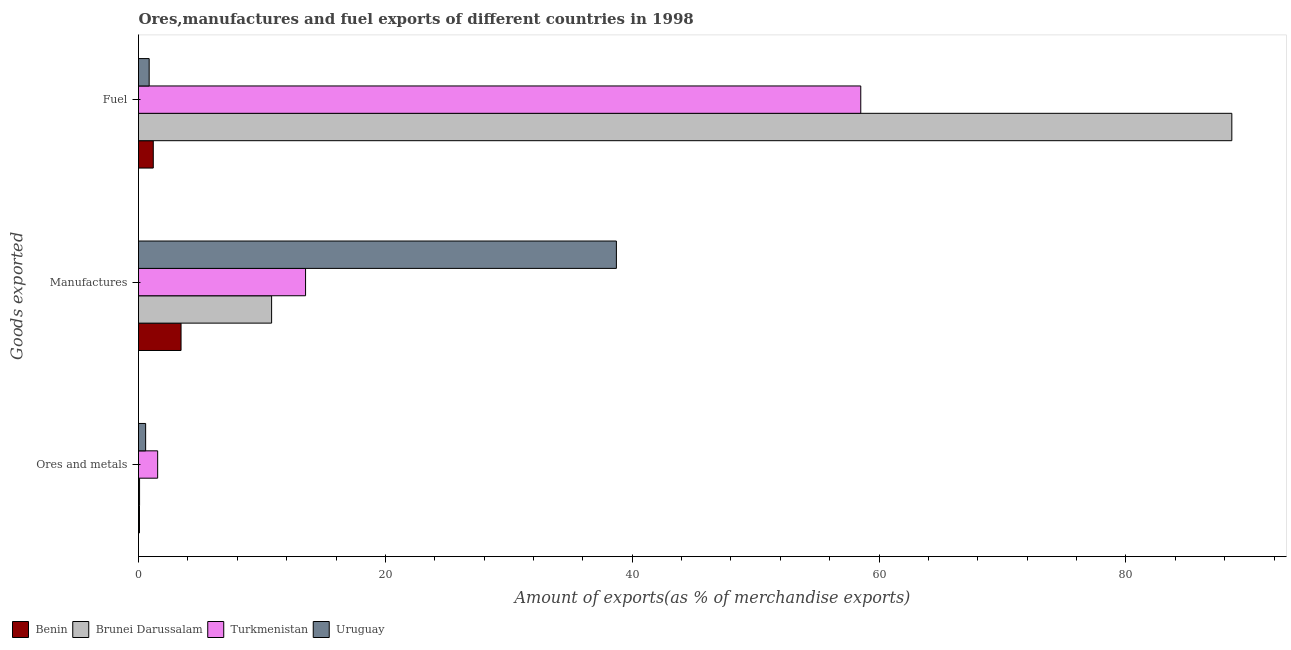How many different coloured bars are there?
Give a very brief answer. 4. How many groups of bars are there?
Your answer should be very brief. 3. Are the number of bars per tick equal to the number of legend labels?
Your answer should be compact. Yes. How many bars are there on the 3rd tick from the top?
Your response must be concise. 4. What is the label of the 3rd group of bars from the top?
Make the answer very short. Ores and metals. What is the percentage of fuel exports in Brunei Darussalam?
Provide a short and direct response. 88.58. Across all countries, what is the maximum percentage of fuel exports?
Offer a very short reply. 88.58. Across all countries, what is the minimum percentage of manufactures exports?
Offer a very short reply. 3.45. In which country was the percentage of manufactures exports maximum?
Offer a terse response. Uruguay. In which country was the percentage of fuel exports minimum?
Make the answer very short. Uruguay. What is the total percentage of fuel exports in the graph?
Provide a short and direct response. 149.15. What is the difference between the percentage of fuel exports in Turkmenistan and that in Brunei Darussalam?
Provide a succinct answer. -30.06. What is the difference between the percentage of manufactures exports in Turkmenistan and the percentage of fuel exports in Uruguay?
Ensure brevity in your answer.  12.67. What is the average percentage of ores and metals exports per country?
Keep it short and to the point. 0.57. What is the difference between the percentage of ores and metals exports and percentage of fuel exports in Brunei Darussalam?
Offer a very short reply. -88.49. In how many countries, is the percentage of fuel exports greater than 44 %?
Ensure brevity in your answer.  2. What is the ratio of the percentage of fuel exports in Brunei Darussalam to that in Uruguay?
Give a very brief answer. 102.54. Is the percentage of manufactures exports in Brunei Darussalam less than that in Uruguay?
Keep it short and to the point. Yes. Is the difference between the percentage of manufactures exports in Turkmenistan and Benin greater than the difference between the percentage of fuel exports in Turkmenistan and Benin?
Give a very brief answer. No. What is the difference between the highest and the second highest percentage of manufactures exports?
Keep it short and to the point. 25.18. What is the difference between the highest and the lowest percentage of ores and metals exports?
Give a very brief answer. 1.47. In how many countries, is the percentage of ores and metals exports greater than the average percentage of ores and metals exports taken over all countries?
Give a very brief answer. 2. What does the 2nd bar from the top in Ores and metals represents?
Your answer should be very brief. Turkmenistan. What does the 4th bar from the bottom in Manufactures represents?
Provide a succinct answer. Uruguay. Is it the case that in every country, the sum of the percentage of ores and metals exports and percentage of manufactures exports is greater than the percentage of fuel exports?
Provide a succinct answer. No. Are the values on the major ticks of X-axis written in scientific E-notation?
Your answer should be compact. No. How many legend labels are there?
Keep it short and to the point. 4. What is the title of the graph?
Ensure brevity in your answer.  Ores,manufactures and fuel exports of different countries in 1998. Does "Angola" appear as one of the legend labels in the graph?
Ensure brevity in your answer.  No. What is the label or title of the X-axis?
Ensure brevity in your answer.  Amount of exports(as % of merchandise exports). What is the label or title of the Y-axis?
Keep it short and to the point. Goods exported. What is the Amount of exports(as % of merchandise exports) of Benin in Ores and metals?
Offer a terse response. 0.08. What is the Amount of exports(as % of merchandise exports) of Brunei Darussalam in Ores and metals?
Give a very brief answer. 0.09. What is the Amount of exports(as % of merchandise exports) in Turkmenistan in Ores and metals?
Keep it short and to the point. 1.55. What is the Amount of exports(as % of merchandise exports) in Uruguay in Ores and metals?
Your answer should be compact. 0.58. What is the Amount of exports(as % of merchandise exports) in Benin in Manufactures?
Keep it short and to the point. 3.45. What is the Amount of exports(as % of merchandise exports) of Brunei Darussalam in Manufactures?
Your response must be concise. 10.78. What is the Amount of exports(as % of merchandise exports) of Turkmenistan in Manufactures?
Your answer should be very brief. 13.53. What is the Amount of exports(as % of merchandise exports) of Uruguay in Manufactures?
Make the answer very short. 38.72. What is the Amount of exports(as % of merchandise exports) in Benin in Fuel?
Your response must be concise. 1.2. What is the Amount of exports(as % of merchandise exports) in Brunei Darussalam in Fuel?
Your answer should be compact. 88.58. What is the Amount of exports(as % of merchandise exports) of Turkmenistan in Fuel?
Your answer should be very brief. 58.51. What is the Amount of exports(as % of merchandise exports) of Uruguay in Fuel?
Give a very brief answer. 0.86. Across all Goods exported, what is the maximum Amount of exports(as % of merchandise exports) of Benin?
Your answer should be compact. 3.45. Across all Goods exported, what is the maximum Amount of exports(as % of merchandise exports) in Brunei Darussalam?
Ensure brevity in your answer.  88.58. Across all Goods exported, what is the maximum Amount of exports(as % of merchandise exports) of Turkmenistan?
Give a very brief answer. 58.51. Across all Goods exported, what is the maximum Amount of exports(as % of merchandise exports) of Uruguay?
Ensure brevity in your answer.  38.72. Across all Goods exported, what is the minimum Amount of exports(as % of merchandise exports) in Benin?
Provide a succinct answer. 0.08. Across all Goods exported, what is the minimum Amount of exports(as % of merchandise exports) in Brunei Darussalam?
Your answer should be very brief. 0.09. Across all Goods exported, what is the minimum Amount of exports(as % of merchandise exports) in Turkmenistan?
Your answer should be very brief. 1.55. Across all Goods exported, what is the minimum Amount of exports(as % of merchandise exports) of Uruguay?
Offer a very short reply. 0.58. What is the total Amount of exports(as % of merchandise exports) in Benin in the graph?
Provide a succinct answer. 4.72. What is the total Amount of exports(as % of merchandise exports) of Brunei Darussalam in the graph?
Keep it short and to the point. 99.45. What is the total Amount of exports(as % of merchandise exports) of Turkmenistan in the graph?
Provide a succinct answer. 73.6. What is the total Amount of exports(as % of merchandise exports) of Uruguay in the graph?
Your answer should be very brief. 40.16. What is the difference between the Amount of exports(as % of merchandise exports) in Benin in Ores and metals and that in Manufactures?
Make the answer very short. -3.37. What is the difference between the Amount of exports(as % of merchandise exports) of Brunei Darussalam in Ores and metals and that in Manufactures?
Your answer should be very brief. -10.7. What is the difference between the Amount of exports(as % of merchandise exports) of Turkmenistan in Ores and metals and that in Manufactures?
Ensure brevity in your answer.  -11.98. What is the difference between the Amount of exports(as % of merchandise exports) of Uruguay in Ores and metals and that in Manufactures?
Provide a short and direct response. -38.14. What is the difference between the Amount of exports(as % of merchandise exports) in Benin in Ores and metals and that in Fuel?
Provide a short and direct response. -1.12. What is the difference between the Amount of exports(as % of merchandise exports) of Brunei Darussalam in Ores and metals and that in Fuel?
Keep it short and to the point. -88.49. What is the difference between the Amount of exports(as % of merchandise exports) of Turkmenistan in Ores and metals and that in Fuel?
Ensure brevity in your answer.  -56.96. What is the difference between the Amount of exports(as % of merchandise exports) in Uruguay in Ores and metals and that in Fuel?
Offer a terse response. -0.29. What is the difference between the Amount of exports(as % of merchandise exports) of Benin in Manufactures and that in Fuel?
Ensure brevity in your answer.  2.25. What is the difference between the Amount of exports(as % of merchandise exports) of Brunei Darussalam in Manufactures and that in Fuel?
Give a very brief answer. -77.79. What is the difference between the Amount of exports(as % of merchandise exports) in Turkmenistan in Manufactures and that in Fuel?
Keep it short and to the point. -44.98. What is the difference between the Amount of exports(as % of merchandise exports) in Uruguay in Manufactures and that in Fuel?
Provide a succinct answer. 37.85. What is the difference between the Amount of exports(as % of merchandise exports) of Benin in Ores and metals and the Amount of exports(as % of merchandise exports) of Brunei Darussalam in Manufactures?
Offer a terse response. -10.71. What is the difference between the Amount of exports(as % of merchandise exports) of Benin in Ores and metals and the Amount of exports(as % of merchandise exports) of Turkmenistan in Manufactures?
Your answer should be compact. -13.46. What is the difference between the Amount of exports(as % of merchandise exports) of Benin in Ores and metals and the Amount of exports(as % of merchandise exports) of Uruguay in Manufactures?
Give a very brief answer. -38.64. What is the difference between the Amount of exports(as % of merchandise exports) of Brunei Darussalam in Ores and metals and the Amount of exports(as % of merchandise exports) of Turkmenistan in Manufactures?
Offer a terse response. -13.45. What is the difference between the Amount of exports(as % of merchandise exports) of Brunei Darussalam in Ores and metals and the Amount of exports(as % of merchandise exports) of Uruguay in Manufactures?
Offer a very short reply. -38.63. What is the difference between the Amount of exports(as % of merchandise exports) in Turkmenistan in Ores and metals and the Amount of exports(as % of merchandise exports) in Uruguay in Manufactures?
Offer a terse response. -37.16. What is the difference between the Amount of exports(as % of merchandise exports) in Benin in Ores and metals and the Amount of exports(as % of merchandise exports) in Brunei Darussalam in Fuel?
Provide a succinct answer. -88.5. What is the difference between the Amount of exports(as % of merchandise exports) in Benin in Ores and metals and the Amount of exports(as % of merchandise exports) in Turkmenistan in Fuel?
Keep it short and to the point. -58.44. What is the difference between the Amount of exports(as % of merchandise exports) of Benin in Ores and metals and the Amount of exports(as % of merchandise exports) of Uruguay in Fuel?
Keep it short and to the point. -0.79. What is the difference between the Amount of exports(as % of merchandise exports) of Brunei Darussalam in Ores and metals and the Amount of exports(as % of merchandise exports) of Turkmenistan in Fuel?
Ensure brevity in your answer.  -58.43. What is the difference between the Amount of exports(as % of merchandise exports) in Brunei Darussalam in Ores and metals and the Amount of exports(as % of merchandise exports) in Uruguay in Fuel?
Make the answer very short. -0.78. What is the difference between the Amount of exports(as % of merchandise exports) of Turkmenistan in Ores and metals and the Amount of exports(as % of merchandise exports) of Uruguay in Fuel?
Offer a terse response. 0.69. What is the difference between the Amount of exports(as % of merchandise exports) of Benin in Manufactures and the Amount of exports(as % of merchandise exports) of Brunei Darussalam in Fuel?
Provide a succinct answer. -85.13. What is the difference between the Amount of exports(as % of merchandise exports) of Benin in Manufactures and the Amount of exports(as % of merchandise exports) of Turkmenistan in Fuel?
Offer a terse response. -55.07. What is the difference between the Amount of exports(as % of merchandise exports) in Benin in Manufactures and the Amount of exports(as % of merchandise exports) in Uruguay in Fuel?
Your answer should be compact. 2.58. What is the difference between the Amount of exports(as % of merchandise exports) of Brunei Darussalam in Manufactures and the Amount of exports(as % of merchandise exports) of Turkmenistan in Fuel?
Provide a succinct answer. -47.73. What is the difference between the Amount of exports(as % of merchandise exports) in Brunei Darussalam in Manufactures and the Amount of exports(as % of merchandise exports) in Uruguay in Fuel?
Offer a very short reply. 9.92. What is the difference between the Amount of exports(as % of merchandise exports) in Turkmenistan in Manufactures and the Amount of exports(as % of merchandise exports) in Uruguay in Fuel?
Make the answer very short. 12.67. What is the average Amount of exports(as % of merchandise exports) in Benin per Goods exported?
Offer a terse response. 1.57. What is the average Amount of exports(as % of merchandise exports) of Brunei Darussalam per Goods exported?
Provide a succinct answer. 33.15. What is the average Amount of exports(as % of merchandise exports) in Turkmenistan per Goods exported?
Provide a succinct answer. 24.53. What is the average Amount of exports(as % of merchandise exports) of Uruguay per Goods exported?
Make the answer very short. 13.39. What is the difference between the Amount of exports(as % of merchandise exports) of Benin and Amount of exports(as % of merchandise exports) of Brunei Darussalam in Ores and metals?
Keep it short and to the point. -0.01. What is the difference between the Amount of exports(as % of merchandise exports) in Benin and Amount of exports(as % of merchandise exports) in Turkmenistan in Ores and metals?
Provide a succinct answer. -1.47. What is the difference between the Amount of exports(as % of merchandise exports) of Benin and Amount of exports(as % of merchandise exports) of Uruguay in Ores and metals?
Give a very brief answer. -0.5. What is the difference between the Amount of exports(as % of merchandise exports) in Brunei Darussalam and Amount of exports(as % of merchandise exports) in Turkmenistan in Ores and metals?
Offer a very short reply. -1.47. What is the difference between the Amount of exports(as % of merchandise exports) of Brunei Darussalam and Amount of exports(as % of merchandise exports) of Uruguay in Ores and metals?
Keep it short and to the point. -0.49. What is the difference between the Amount of exports(as % of merchandise exports) in Turkmenistan and Amount of exports(as % of merchandise exports) in Uruguay in Ores and metals?
Offer a very short reply. 0.97. What is the difference between the Amount of exports(as % of merchandise exports) of Benin and Amount of exports(as % of merchandise exports) of Brunei Darussalam in Manufactures?
Make the answer very short. -7.34. What is the difference between the Amount of exports(as % of merchandise exports) of Benin and Amount of exports(as % of merchandise exports) of Turkmenistan in Manufactures?
Provide a succinct answer. -10.09. What is the difference between the Amount of exports(as % of merchandise exports) of Benin and Amount of exports(as % of merchandise exports) of Uruguay in Manufactures?
Offer a terse response. -35.27. What is the difference between the Amount of exports(as % of merchandise exports) in Brunei Darussalam and Amount of exports(as % of merchandise exports) in Turkmenistan in Manufactures?
Your answer should be very brief. -2.75. What is the difference between the Amount of exports(as % of merchandise exports) of Brunei Darussalam and Amount of exports(as % of merchandise exports) of Uruguay in Manufactures?
Offer a very short reply. -27.93. What is the difference between the Amount of exports(as % of merchandise exports) in Turkmenistan and Amount of exports(as % of merchandise exports) in Uruguay in Manufactures?
Give a very brief answer. -25.18. What is the difference between the Amount of exports(as % of merchandise exports) in Benin and Amount of exports(as % of merchandise exports) in Brunei Darussalam in Fuel?
Offer a very short reply. -87.38. What is the difference between the Amount of exports(as % of merchandise exports) of Benin and Amount of exports(as % of merchandise exports) of Turkmenistan in Fuel?
Provide a short and direct response. -57.32. What is the difference between the Amount of exports(as % of merchandise exports) in Benin and Amount of exports(as % of merchandise exports) in Uruguay in Fuel?
Make the answer very short. 0.33. What is the difference between the Amount of exports(as % of merchandise exports) of Brunei Darussalam and Amount of exports(as % of merchandise exports) of Turkmenistan in Fuel?
Your response must be concise. 30.06. What is the difference between the Amount of exports(as % of merchandise exports) of Brunei Darussalam and Amount of exports(as % of merchandise exports) of Uruguay in Fuel?
Your answer should be very brief. 87.71. What is the difference between the Amount of exports(as % of merchandise exports) of Turkmenistan and Amount of exports(as % of merchandise exports) of Uruguay in Fuel?
Provide a short and direct response. 57.65. What is the ratio of the Amount of exports(as % of merchandise exports) in Benin in Ores and metals to that in Manufactures?
Your answer should be very brief. 0.02. What is the ratio of the Amount of exports(as % of merchandise exports) in Brunei Darussalam in Ores and metals to that in Manufactures?
Keep it short and to the point. 0.01. What is the ratio of the Amount of exports(as % of merchandise exports) in Turkmenistan in Ores and metals to that in Manufactures?
Your answer should be compact. 0.11. What is the ratio of the Amount of exports(as % of merchandise exports) in Uruguay in Ores and metals to that in Manufactures?
Your answer should be compact. 0.01. What is the ratio of the Amount of exports(as % of merchandise exports) of Benin in Ores and metals to that in Fuel?
Your answer should be very brief. 0.06. What is the ratio of the Amount of exports(as % of merchandise exports) of Turkmenistan in Ores and metals to that in Fuel?
Make the answer very short. 0.03. What is the ratio of the Amount of exports(as % of merchandise exports) of Uruguay in Ores and metals to that in Fuel?
Ensure brevity in your answer.  0.67. What is the ratio of the Amount of exports(as % of merchandise exports) of Benin in Manufactures to that in Fuel?
Your answer should be very brief. 2.88. What is the ratio of the Amount of exports(as % of merchandise exports) in Brunei Darussalam in Manufactures to that in Fuel?
Your answer should be very brief. 0.12. What is the ratio of the Amount of exports(as % of merchandise exports) in Turkmenistan in Manufactures to that in Fuel?
Provide a succinct answer. 0.23. What is the ratio of the Amount of exports(as % of merchandise exports) in Uruguay in Manufactures to that in Fuel?
Provide a short and direct response. 44.82. What is the difference between the highest and the second highest Amount of exports(as % of merchandise exports) in Benin?
Ensure brevity in your answer.  2.25. What is the difference between the highest and the second highest Amount of exports(as % of merchandise exports) of Brunei Darussalam?
Provide a short and direct response. 77.79. What is the difference between the highest and the second highest Amount of exports(as % of merchandise exports) of Turkmenistan?
Give a very brief answer. 44.98. What is the difference between the highest and the second highest Amount of exports(as % of merchandise exports) of Uruguay?
Give a very brief answer. 37.85. What is the difference between the highest and the lowest Amount of exports(as % of merchandise exports) in Benin?
Provide a short and direct response. 3.37. What is the difference between the highest and the lowest Amount of exports(as % of merchandise exports) of Brunei Darussalam?
Provide a short and direct response. 88.49. What is the difference between the highest and the lowest Amount of exports(as % of merchandise exports) in Turkmenistan?
Offer a terse response. 56.96. What is the difference between the highest and the lowest Amount of exports(as % of merchandise exports) of Uruguay?
Offer a very short reply. 38.14. 